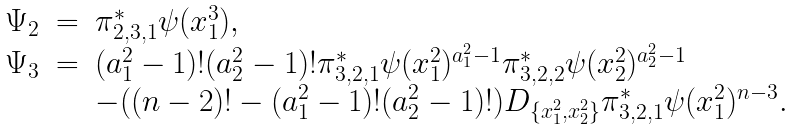<formula> <loc_0><loc_0><loc_500><loc_500>\begin{array} { r c l } \Psi _ { 2 } & = & \pi _ { 2 , 3 , 1 } ^ { * } \psi ( x ^ { 3 } _ { 1 } ) , \\ \Psi _ { 3 } & = & ( a ^ { 2 } _ { 1 } - 1 ) ! ( a ^ { 2 } _ { 2 } - 1 ) ! \pi _ { 3 , 2 , 1 } ^ { * } \psi ( x ^ { 2 } _ { 1 } ) ^ { a ^ { 2 } _ { 1 } - 1 } \pi _ { 3 , 2 , 2 } ^ { * } \psi ( x ^ { 2 } _ { 2 } ) ^ { a ^ { 2 } _ { 2 } - 1 } \\ & & - ( ( n - 2 ) ! - ( a ^ { 2 } _ { 1 } - 1 ) ! ( a ^ { 2 } _ { 2 } - 1 ) ! ) D _ { \{ x ^ { 2 } _ { 1 } , x ^ { 2 } _ { 2 } \} } \pi _ { 3 , 2 , 1 } ^ { * } \psi ( x ^ { 2 } _ { 1 } ) ^ { n - 3 } . \end{array}</formula> 